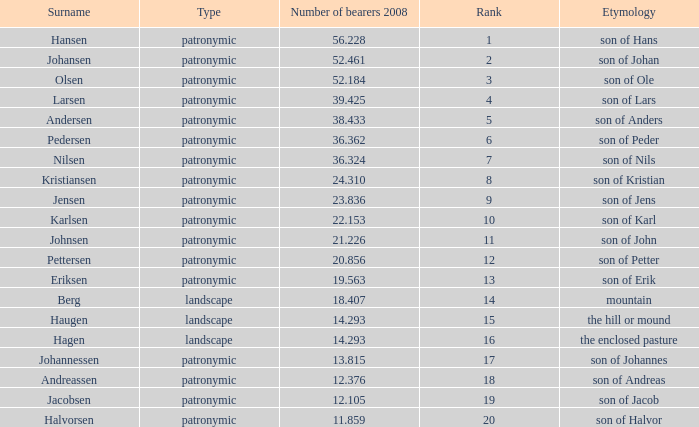What is the highest Number of Bearers 2008, when Surname is Hansen, and when Rank is less than 1? None. 